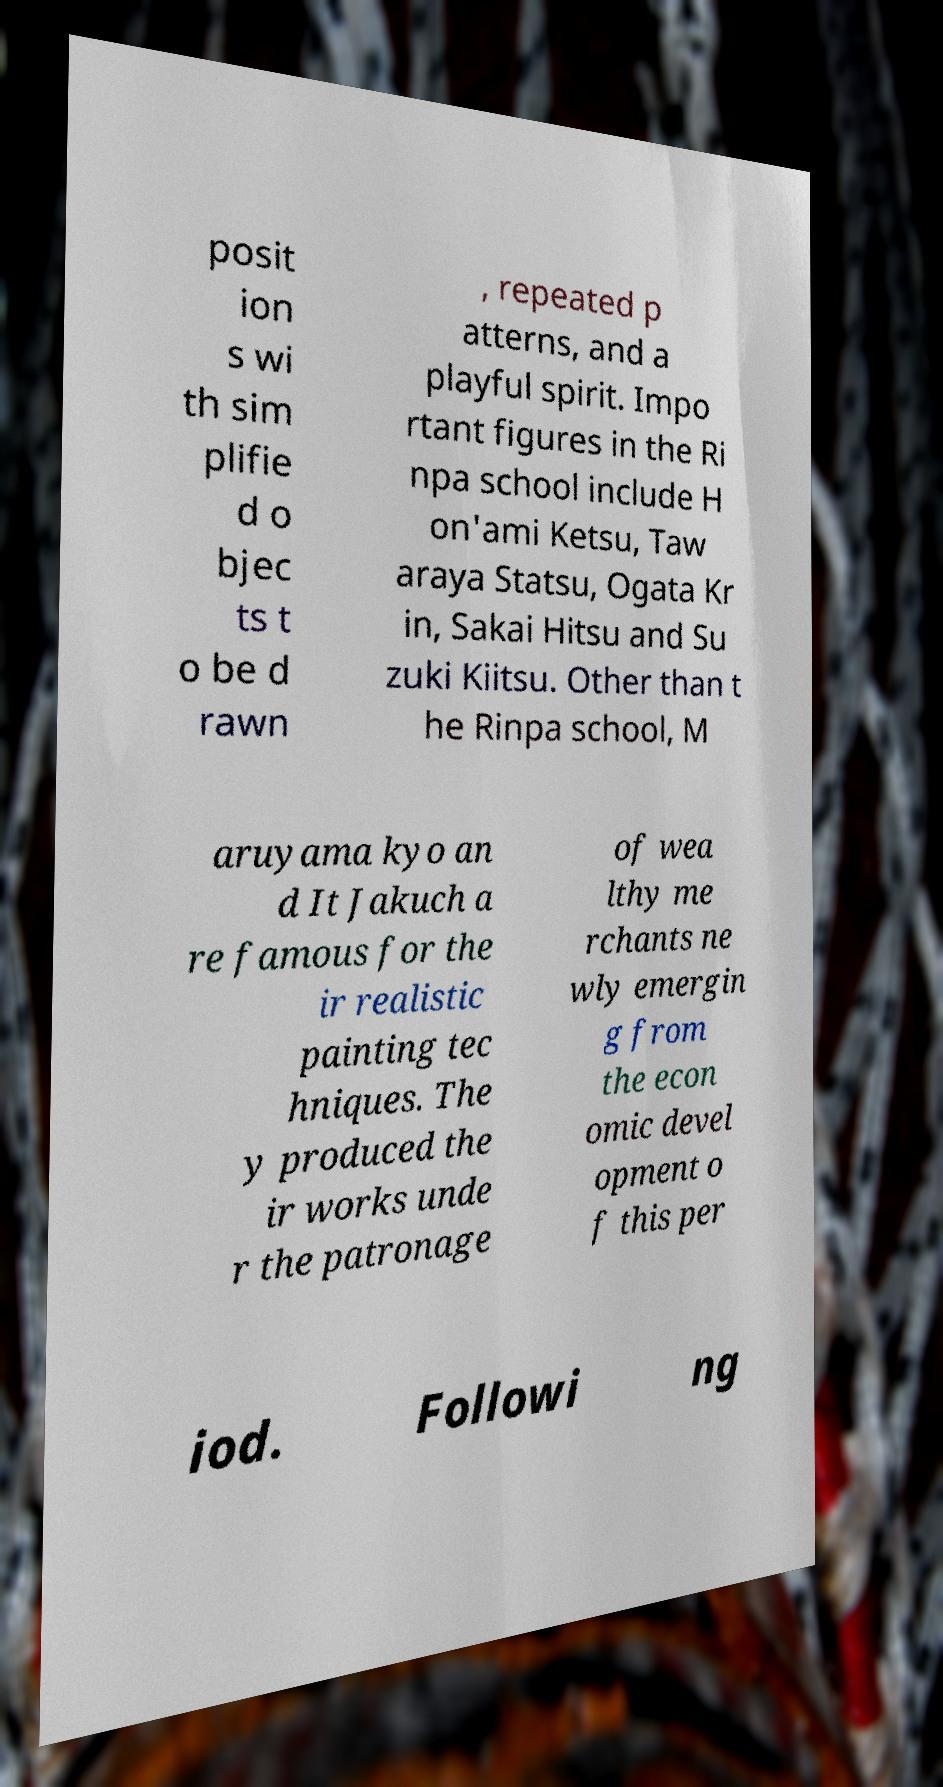Could you assist in decoding the text presented in this image and type it out clearly? posit ion s wi th sim plifie d o bjec ts t o be d rawn , repeated p atterns, and a playful spirit. Impo rtant figures in the Ri npa school include H on'ami Ketsu, Taw araya Statsu, Ogata Kr in, Sakai Hitsu and Su zuki Kiitsu. Other than t he Rinpa school, M aruyama kyo an d It Jakuch a re famous for the ir realistic painting tec hniques. The y produced the ir works unde r the patronage of wea lthy me rchants ne wly emergin g from the econ omic devel opment o f this per iod. Followi ng 